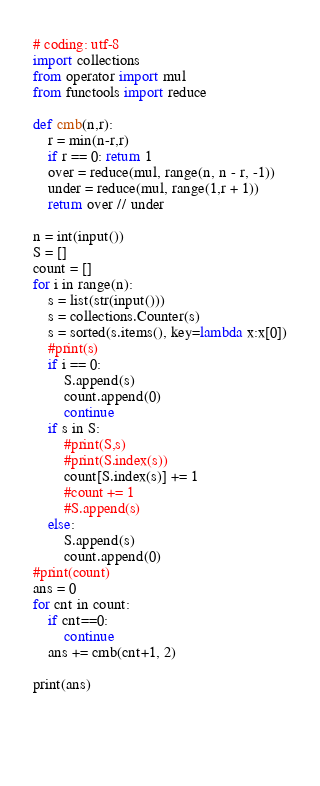Convert code to text. <code><loc_0><loc_0><loc_500><loc_500><_Python_># coding: utf-8
import collections
from operator import mul
from functools import reduce

def cmb(n,r):
    r = min(n-r,r)
    if r == 0: return 1
    over = reduce(mul, range(n, n - r, -1))
    under = reduce(mul, range(1,r + 1))
    return over // under
    
n = int(input())
S = []
count = []
for i in range(n):
    s = list(str(input()))
    s = collections.Counter(s)
    s = sorted(s.items(), key=lambda x:x[0])
    #print(s)
    if i == 0:
        S.append(s)
        count.append(0)
        continue
    if s in S:
        #print(S,s)
        #print(S.index(s))
        count[S.index(s)] += 1
        #count += 1
        #S.append(s)
    else:
        S.append(s)
        count.append(0)
#print(count)
ans = 0
for cnt in count:
    if cnt==0:
        continue
    ans += cmb(cnt+1, 2)
    
print(ans)

    

    </code> 